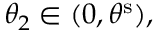Convert formula to latex. <formula><loc_0><loc_0><loc_500><loc_500>\theta _ { 2 } \in ( 0 , \theta ^ { s } ) ,</formula> 